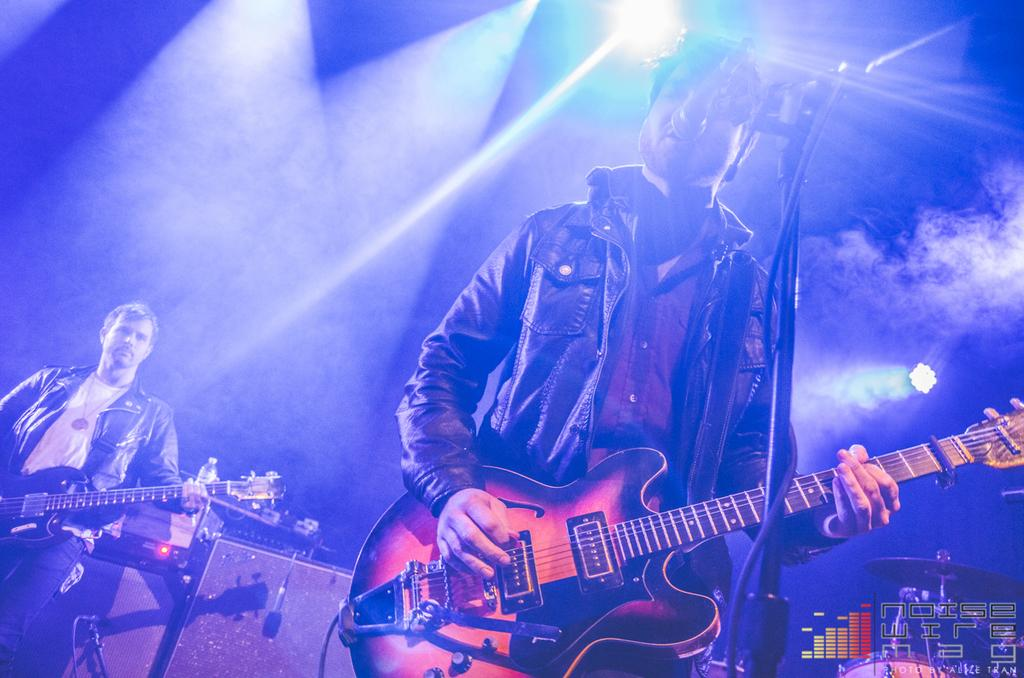How many men are in the image? There are two men in the image. What are the men doing in the image? Both men are holding guitars and playing them. One of the men is also singing into a microphone. What other instruments can be seen in the background of the image? There are drums in the background of the image. What equipment is present in the background of the image to amplify the sound? There are speakers in the background of the image. What additional items can be seen in the background of the image? There is a bottle, additional microphones, a light, and smoke visible in the background of the image. What religious beliefs do the men in the image follow? There is no information about the men's religious beliefs in the image. What type of ink is being used to write on the bottle in the image? There is no writing or ink visible on the bottle in the image. 